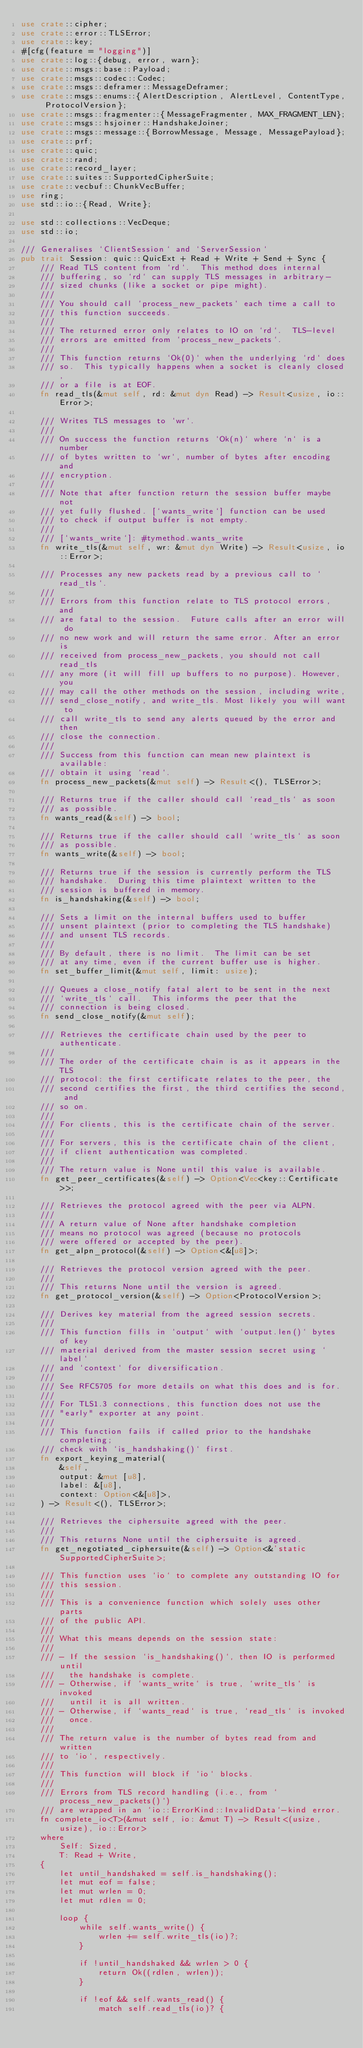Convert code to text. <code><loc_0><loc_0><loc_500><loc_500><_Rust_>use crate::cipher;
use crate::error::TLSError;
use crate::key;
#[cfg(feature = "logging")]
use crate::log::{debug, error, warn};
use crate::msgs::base::Payload;
use crate::msgs::codec::Codec;
use crate::msgs::deframer::MessageDeframer;
use crate::msgs::enums::{AlertDescription, AlertLevel, ContentType, ProtocolVersion};
use crate::msgs::fragmenter::{MessageFragmenter, MAX_FRAGMENT_LEN};
use crate::msgs::hsjoiner::HandshakeJoiner;
use crate::msgs::message::{BorrowMessage, Message, MessagePayload};
use crate::prf;
use crate::quic;
use crate::rand;
use crate::record_layer;
use crate::suites::SupportedCipherSuite;
use crate::vecbuf::ChunkVecBuffer;
use ring;
use std::io::{Read, Write};

use std::collections::VecDeque;
use std::io;

/// Generalises `ClientSession` and `ServerSession`
pub trait Session: quic::QuicExt + Read + Write + Send + Sync {
    /// Read TLS content from `rd`.  This method does internal
    /// buffering, so `rd` can supply TLS messages in arbitrary-
    /// sized chunks (like a socket or pipe might).
    ///
    /// You should call `process_new_packets` each time a call to
    /// this function succeeds.
    ///
    /// The returned error only relates to IO on `rd`.  TLS-level
    /// errors are emitted from `process_new_packets`.
    ///
    /// This function returns `Ok(0)` when the underlying `rd` does
    /// so.  This typically happens when a socket is cleanly closed,
    /// or a file is at EOF.
    fn read_tls(&mut self, rd: &mut dyn Read) -> Result<usize, io::Error>;

    /// Writes TLS messages to `wr`.
    ///
    /// On success the function returns `Ok(n)` where `n` is a number
    /// of bytes written to `wr`, number of bytes after encoding and
    /// encryption.
    ///
    /// Note that after function return the session buffer maybe not
    /// yet fully flushed. [`wants_write`] function can be used
    /// to check if output buffer is not empty.
    ///
    /// [`wants_write`]: #tymethod.wants_write
    fn write_tls(&mut self, wr: &mut dyn Write) -> Result<usize, io::Error>;

    /// Processes any new packets read by a previous call to `read_tls`.
    ///
    /// Errors from this function relate to TLS protocol errors, and
    /// are fatal to the session.  Future calls after an error will do
    /// no new work and will return the same error. After an error is
    /// received from process_new_packets, you should not call read_tls
    /// any more (it will fill up buffers to no purpose). However, you
    /// may call the other methods on the session, including write,
    /// send_close_notify, and write_tls. Most likely you will want to
    /// call write_tls to send any alerts queued by the error and then
    /// close the connection.
    ///
    /// Success from this function can mean new plaintext is available:
    /// obtain it using `read`.
    fn process_new_packets(&mut self) -> Result<(), TLSError>;

    /// Returns true if the caller should call `read_tls` as soon
    /// as possible.
    fn wants_read(&self) -> bool;

    /// Returns true if the caller should call `write_tls` as soon
    /// as possible.
    fn wants_write(&self) -> bool;

    /// Returns true if the session is currently perform the TLS
    /// handshake.  During this time plaintext written to the
    /// session is buffered in memory.
    fn is_handshaking(&self) -> bool;

    /// Sets a limit on the internal buffers used to buffer
    /// unsent plaintext (prior to completing the TLS handshake)
    /// and unsent TLS records.
    ///
    /// By default, there is no limit.  The limit can be set
    /// at any time, even if the current buffer use is higher.
    fn set_buffer_limit(&mut self, limit: usize);

    /// Queues a close_notify fatal alert to be sent in the next
    /// `write_tls` call.  This informs the peer that the
    /// connection is being closed.
    fn send_close_notify(&mut self);

    /// Retrieves the certificate chain used by the peer to authenticate.
    ///
    /// The order of the certificate chain is as it appears in the TLS
    /// protocol: the first certificate relates to the peer, the
    /// second certifies the first, the third certifies the second, and
    /// so on.
    ///
    /// For clients, this is the certificate chain of the server.
    ///
    /// For servers, this is the certificate chain of the client,
    /// if client authentication was completed.
    ///
    /// The return value is None until this value is available.
    fn get_peer_certificates(&self) -> Option<Vec<key::Certificate>>;

    /// Retrieves the protocol agreed with the peer via ALPN.
    ///
    /// A return value of None after handshake completion
    /// means no protocol was agreed (because no protocols
    /// were offered or accepted by the peer).
    fn get_alpn_protocol(&self) -> Option<&[u8]>;

    /// Retrieves the protocol version agreed with the peer.
    ///
    /// This returns None until the version is agreed.
    fn get_protocol_version(&self) -> Option<ProtocolVersion>;

    /// Derives key material from the agreed session secrets.
    ///
    /// This function fills in `output` with `output.len()` bytes of key
    /// material derived from the master session secret using `label`
    /// and `context` for diversification.
    ///
    /// See RFC5705 for more details on what this does and is for.
    ///
    /// For TLS1.3 connections, this function does not use the
    /// "early" exporter at any point.
    ///
    /// This function fails if called prior to the handshake completing;
    /// check with `is_handshaking()` first.
    fn export_keying_material(
        &self,
        output: &mut [u8],
        label: &[u8],
        context: Option<&[u8]>,
    ) -> Result<(), TLSError>;

    /// Retrieves the ciphersuite agreed with the peer.
    ///
    /// This returns None until the ciphersuite is agreed.
    fn get_negotiated_ciphersuite(&self) -> Option<&'static SupportedCipherSuite>;

    /// This function uses `io` to complete any outstanding IO for
    /// this session.
    ///
    /// This is a convenience function which solely uses other parts
    /// of the public API.
    ///
    /// What this means depends on the session state:
    ///
    /// - If the session `is_handshaking()`, then IO is performed until
    ///   the handshake is complete.
    /// - Otherwise, if `wants_write` is true, `write_tls` is invoked
    ///   until it is all written.
    /// - Otherwise, if `wants_read` is true, `read_tls` is invoked
    ///   once.
    ///
    /// The return value is the number of bytes read from and written
    /// to `io`, respectively.
    ///
    /// This function will block if `io` blocks.
    ///
    /// Errors from TLS record handling (i.e., from `process_new_packets()`)
    /// are wrapped in an `io::ErrorKind::InvalidData`-kind error.
    fn complete_io<T>(&mut self, io: &mut T) -> Result<(usize, usize), io::Error>
    where
        Self: Sized,
        T: Read + Write,
    {
        let until_handshaked = self.is_handshaking();
        let mut eof = false;
        let mut wrlen = 0;
        let mut rdlen = 0;

        loop {
            while self.wants_write() {
                wrlen += self.write_tls(io)?;
            }

            if !until_handshaked && wrlen > 0 {
                return Ok((rdlen, wrlen));
            }

            if !eof && self.wants_read() {
                match self.read_tls(io)? {</code> 